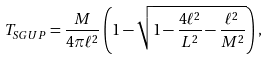Convert formula to latex. <formula><loc_0><loc_0><loc_500><loc_500>T _ { S G U P } = \frac { M } { 4 \pi \ell ^ { 2 } } \left ( 1 - \sqrt { 1 - \frac { 4 \ell ^ { 2 } } { L ^ { 2 } } - \frac { \ell ^ { 2 } } { M ^ { 2 } } } \right ) ,</formula> 